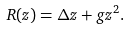<formula> <loc_0><loc_0><loc_500><loc_500>R ( z ) = \Delta z + g z ^ { 2 } .</formula> 